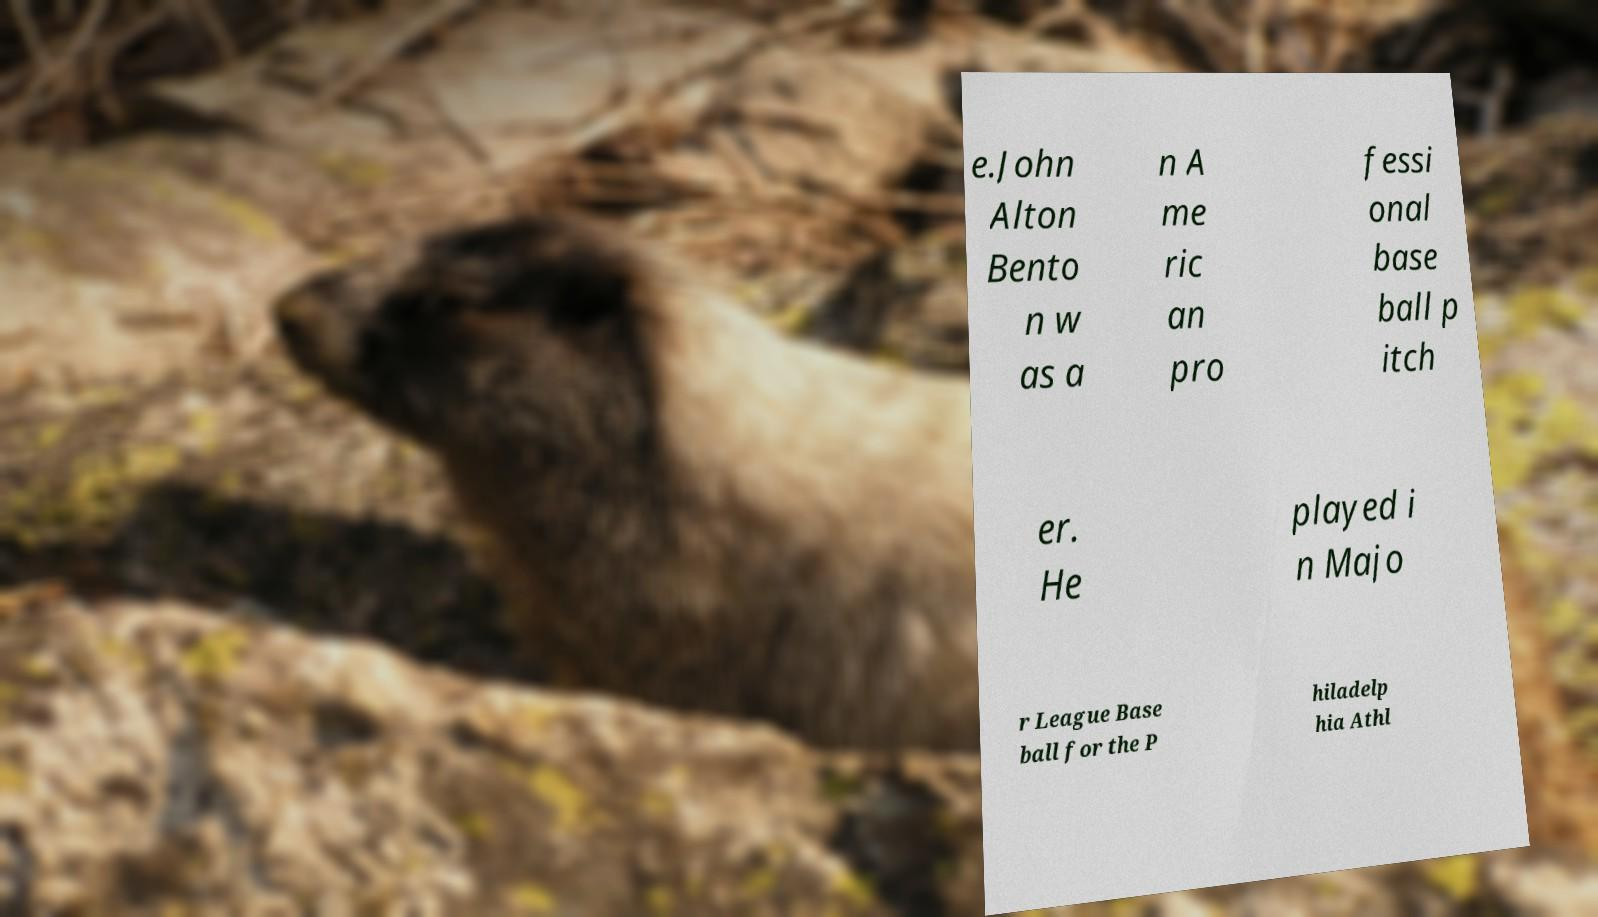What messages or text are displayed in this image? I need them in a readable, typed format. e.John Alton Bento n w as a n A me ric an pro fessi onal base ball p itch er. He played i n Majo r League Base ball for the P hiladelp hia Athl 